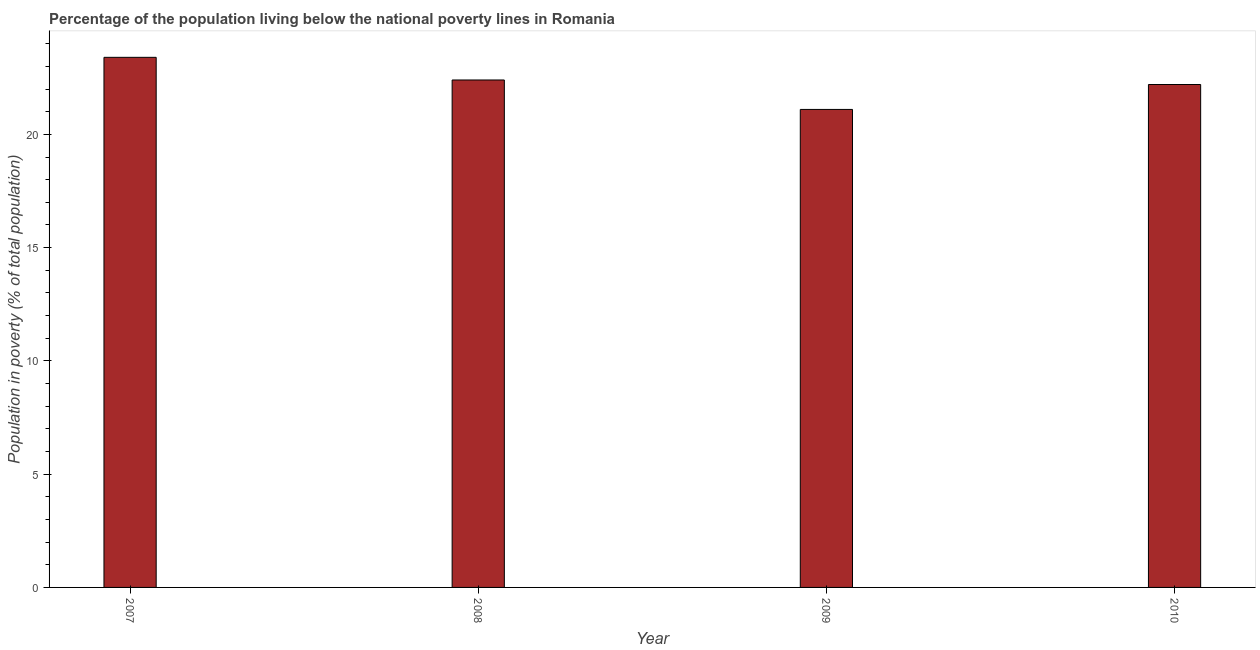Does the graph contain any zero values?
Your response must be concise. No. Does the graph contain grids?
Provide a succinct answer. No. What is the title of the graph?
Provide a short and direct response. Percentage of the population living below the national poverty lines in Romania. What is the label or title of the X-axis?
Ensure brevity in your answer.  Year. What is the label or title of the Y-axis?
Your response must be concise. Population in poverty (% of total population). What is the percentage of population living below poverty line in 2008?
Your response must be concise. 22.4. Across all years, what is the maximum percentage of population living below poverty line?
Give a very brief answer. 23.4. Across all years, what is the minimum percentage of population living below poverty line?
Your answer should be very brief. 21.1. In which year was the percentage of population living below poverty line maximum?
Give a very brief answer. 2007. What is the sum of the percentage of population living below poverty line?
Your answer should be very brief. 89.1. What is the difference between the percentage of population living below poverty line in 2009 and 2010?
Make the answer very short. -1.1. What is the average percentage of population living below poverty line per year?
Offer a very short reply. 22.27. What is the median percentage of population living below poverty line?
Your answer should be very brief. 22.3. Do a majority of the years between 2008 and 2009 (inclusive) have percentage of population living below poverty line greater than 6 %?
Give a very brief answer. Yes. What is the ratio of the percentage of population living below poverty line in 2007 to that in 2009?
Provide a succinct answer. 1.11. Is the percentage of population living below poverty line in 2009 less than that in 2010?
Your answer should be very brief. Yes. What is the difference between the highest and the second highest percentage of population living below poverty line?
Make the answer very short. 1. Is the sum of the percentage of population living below poverty line in 2008 and 2010 greater than the maximum percentage of population living below poverty line across all years?
Provide a short and direct response. Yes. What is the difference between the highest and the lowest percentage of population living below poverty line?
Give a very brief answer. 2.3. How many bars are there?
Provide a short and direct response. 4. Are all the bars in the graph horizontal?
Your response must be concise. No. How many years are there in the graph?
Keep it short and to the point. 4. What is the Population in poverty (% of total population) in 2007?
Your answer should be very brief. 23.4. What is the Population in poverty (% of total population) in 2008?
Your response must be concise. 22.4. What is the Population in poverty (% of total population) in 2009?
Provide a short and direct response. 21.1. What is the Population in poverty (% of total population) of 2010?
Your response must be concise. 22.2. What is the difference between the Population in poverty (% of total population) in 2007 and 2010?
Give a very brief answer. 1.2. What is the difference between the Population in poverty (% of total population) in 2008 and 2010?
Provide a short and direct response. 0.2. What is the difference between the Population in poverty (% of total population) in 2009 and 2010?
Provide a succinct answer. -1.1. What is the ratio of the Population in poverty (% of total population) in 2007 to that in 2008?
Ensure brevity in your answer.  1.04. What is the ratio of the Population in poverty (% of total population) in 2007 to that in 2009?
Make the answer very short. 1.11. What is the ratio of the Population in poverty (% of total population) in 2007 to that in 2010?
Ensure brevity in your answer.  1.05. What is the ratio of the Population in poverty (% of total population) in 2008 to that in 2009?
Provide a short and direct response. 1.06. What is the ratio of the Population in poverty (% of total population) in 2009 to that in 2010?
Give a very brief answer. 0.95. 